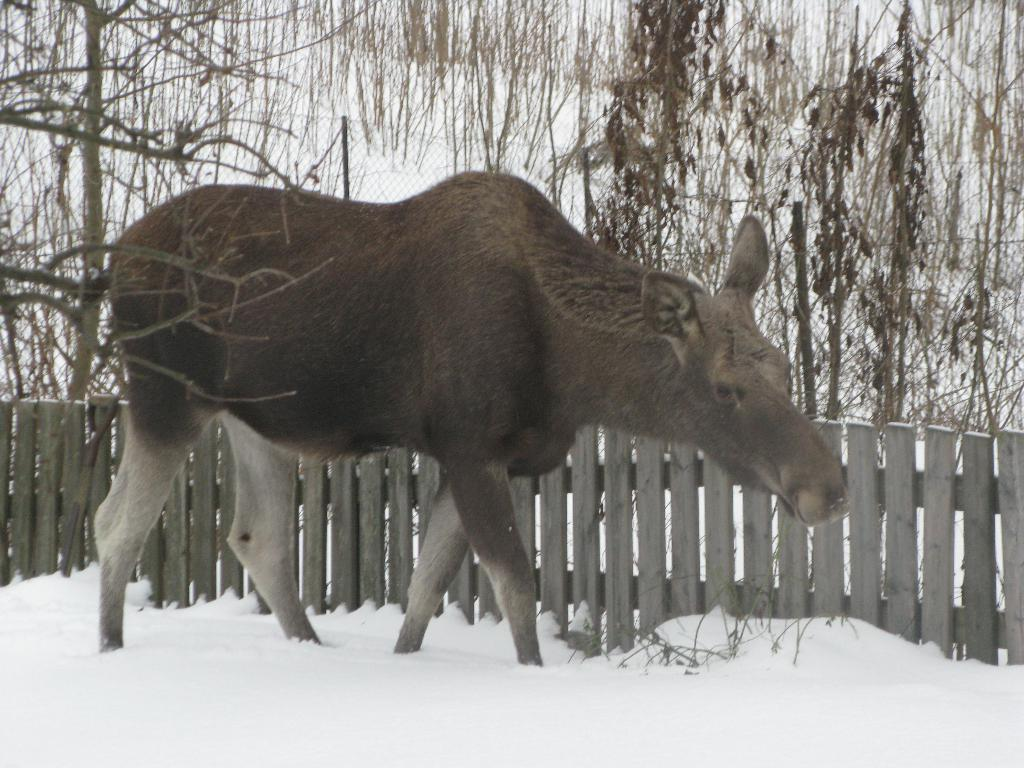What type of animal can be seen in the image? There is an animal in the image, but we cannot determine the specific type without more information. What is the weather like in the image? There is snow in the image, which suggests a cold and wintry environment. What is the purpose of the fence in the image? The purpose of the fence in the image is not clear, but it could be used for containing the animal or marking a boundary. What type of vegetation is present in the image? There are trees in the image, which provide a natural backdrop. What type of clover is growing in the image? There is no clover present in the image; it features an animal, snow, a fence, and trees. What type of instrument is being played in the image? There is no instrument present in the image; it features an animal, snow, a fence, and trees. 